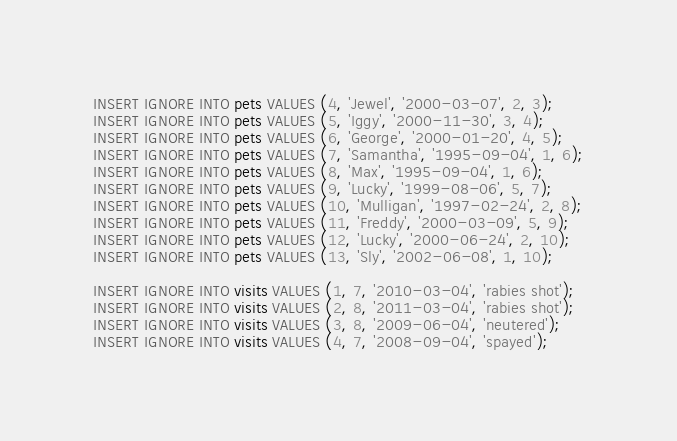<code> <loc_0><loc_0><loc_500><loc_500><_SQL_>INSERT IGNORE INTO pets VALUES (4, 'Jewel', '2000-03-07', 2, 3);
INSERT IGNORE INTO pets VALUES (5, 'Iggy', '2000-11-30', 3, 4);
INSERT IGNORE INTO pets VALUES (6, 'George', '2000-01-20', 4, 5);
INSERT IGNORE INTO pets VALUES (7, 'Samantha', '1995-09-04', 1, 6);
INSERT IGNORE INTO pets VALUES (8, 'Max', '1995-09-04', 1, 6);
INSERT IGNORE INTO pets VALUES (9, 'Lucky', '1999-08-06', 5, 7);
INSERT IGNORE INTO pets VALUES (10, 'Mulligan', '1997-02-24', 2, 8);
INSERT IGNORE INTO pets VALUES (11, 'Freddy', '2000-03-09', 5, 9);
INSERT IGNORE INTO pets VALUES (12, 'Lucky', '2000-06-24', 2, 10);
INSERT IGNORE INTO pets VALUES (13, 'Sly', '2002-06-08', 1, 10);

INSERT IGNORE INTO visits VALUES (1, 7, '2010-03-04', 'rabies shot');
INSERT IGNORE INTO visits VALUES (2, 8, '2011-03-04', 'rabies shot');
INSERT IGNORE INTO visits VALUES (3, 8, '2009-06-04', 'neutered');
INSERT IGNORE INTO visits VALUES (4, 7, '2008-09-04', 'spayed');
</code> 